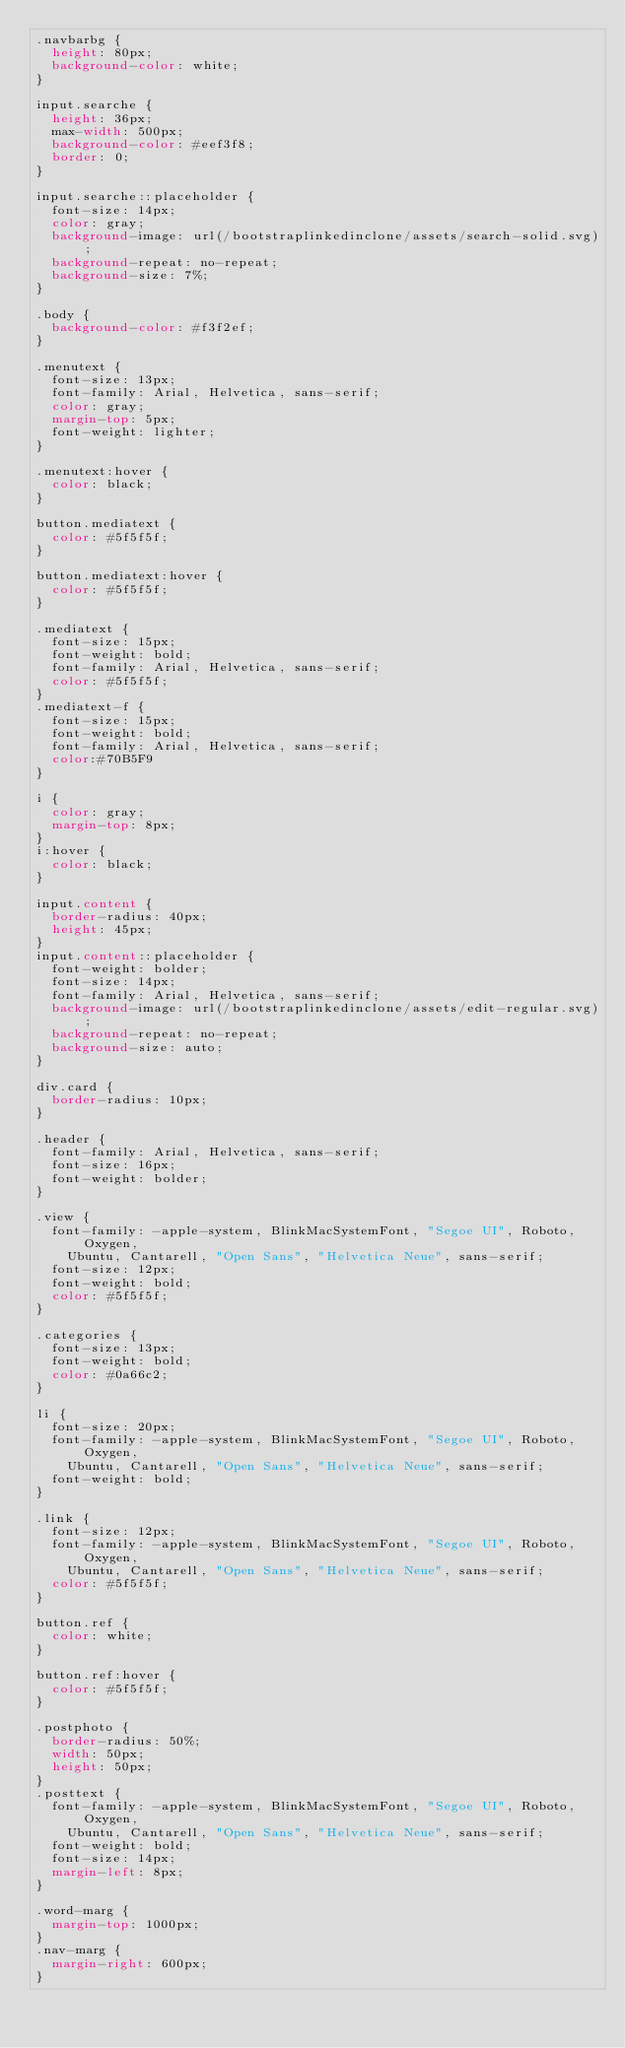<code> <loc_0><loc_0><loc_500><loc_500><_CSS_>.navbarbg {
  height: 80px;
  background-color: white;
}

input.searche {
  height: 36px;
  max-width: 500px;
  background-color: #eef3f8;
  border: 0;
}

input.searche::placeholder {
  font-size: 14px;
  color: gray;
  background-image: url(/bootstraplinkedinclone/assets/search-solid.svg);
  background-repeat: no-repeat;
  background-size: 7%;
}

.body {
  background-color: #f3f2ef;
}

.menutext {
  font-size: 13px;
  font-family: Arial, Helvetica, sans-serif;
  color: gray;
  margin-top: 5px;
  font-weight: lighter;
}

.menutext:hover {
  color: black;
}

button.mediatext {
  color: #5f5f5f;
}

button.mediatext:hover {
  color: #5f5f5f;
}

.mediatext {
  font-size: 15px;
  font-weight: bold;
  font-family: Arial, Helvetica, sans-serif;
  color: #5f5f5f;
}
.mediatext-f {
  font-size: 15px;
  font-weight: bold;
  font-family: Arial, Helvetica, sans-serif;
  color:#70B5F9
}

i {
  color: gray;
  margin-top: 8px;
}
i:hover {
  color: black;
}

input.content {
  border-radius: 40px;
  height: 45px;
}
input.content::placeholder {
  font-weight: bolder;
  font-size: 14px;
  font-family: Arial, Helvetica, sans-serif;
  background-image: url(/bootstraplinkedinclone/assets/edit-regular.svg);
  background-repeat: no-repeat;
  background-size: auto;
}

div.card {
  border-radius: 10px;
}

.header {
  font-family: Arial, Helvetica, sans-serif;
  font-size: 16px;
  font-weight: bolder;
}

.view {
  font-family: -apple-system, BlinkMacSystemFont, "Segoe UI", Roboto, Oxygen,
    Ubuntu, Cantarell, "Open Sans", "Helvetica Neue", sans-serif;
  font-size: 12px;
  font-weight: bold;
  color: #5f5f5f;
}

.categories {
  font-size: 13px;
  font-weight: bold;
  color: #0a66c2;
}

li {
  font-size: 20px;
  font-family: -apple-system, BlinkMacSystemFont, "Segoe UI", Roboto, Oxygen,
    Ubuntu, Cantarell, "Open Sans", "Helvetica Neue", sans-serif;
  font-weight: bold;
}

.link {
  font-size: 12px;
  font-family: -apple-system, BlinkMacSystemFont, "Segoe UI", Roboto, Oxygen,
    Ubuntu, Cantarell, "Open Sans", "Helvetica Neue", sans-serif;
  color: #5f5f5f;
}

button.ref {
  color: white;
}

button.ref:hover {
  color: #5f5f5f;
}

.postphoto {
  border-radius: 50%;
  width: 50px;
  height: 50px;
}
.posttext {
  font-family: -apple-system, BlinkMacSystemFont, "Segoe UI", Roboto, Oxygen,
    Ubuntu, Cantarell, "Open Sans", "Helvetica Neue", sans-serif;
  font-weight: bold;
  font-size: 14px;
  margin-left: 8px;
}

.word-marg {
  margin-top: 1000px;
}
.nav-marg {
  margin-right: 600px;
}</code> 